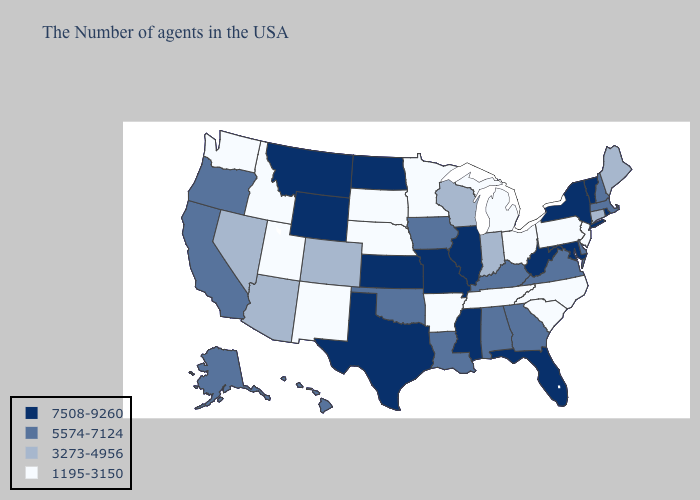Name the states that have a value in the range 7508-9260?
Short answer required. Rhode Island, Vermont, New York, Maryland, West Virginia, Florida, Illinois, Mississippi, Missouri, Kansas, Texas, North Dakota, Wyoming, Montana. Which states have the highest value in the USA?
Keep it brief. Rhode Island, Vermont, New York, Maryland, West Virginia, Florida, Illinois, Mississippi, Missouri, Kansas, Texas, North Dakota, Wyoming, Montana. Among the states that border Wisconsin , does Iowa have the highest value?
Write a very short answer. No. Which states have the highest value in the USA?
Quick response, please. Rhode Island, Vermont, New York, Maryland, West Virginia, Florida, Illinois, Mississippi, Missouri, Kansas, Texas, North Dakota, Wyoming, Montana. What is the value of Illinois?
Quick response, please. 7508-9260. Which states have the highest value in the USA?
Give a very brief answer. Rhode Island, Vermont, New York, Maryland, West Virginia, Florida, Illinois, Mississippi, Missouri, Kansas, Texas, North Dakota, Wyoming, Montana. Which states have the highest value in the USA?
Short answer required. Rhode Island, Vermont, New York, Maryland, West Virginia, Florida, Illinois, Mississippi, Missouri, Kansas, Texas, North Dakota, Wyoming, Montana. Among the states that border Mississippi , does Alabama have the highest value?
Give a very brief answer. Yes. Which states have the lowest value in the West?
Be succinct. New Mexico, Utah, Idaho, Washington. What is the lowest value in the USA?
Quick response, please. 1195-3150. Is the legend a continuous bar?
Be succinct. No. Name the states that have a value in the range 7508-9260?
Short answer required. Rhode Island, Vermont, New York, Maryland, West Virginia, Florida, Illinois, Mississippi, Missouri, Kansas, Texas, North Dakota, Wyoming, Montana. Among the states that border Missouri , does Kentucky have the highest value?
Concise answer only. No. What is the lowest value in states that border New Jersey?
Concise answer only. 1195-3150. Name the states that have a value in the range 3273-4956?
Be succinct. Maine, Connecticut, Indiana, Wisconsin, Colorado, Arizona, Nevada. 